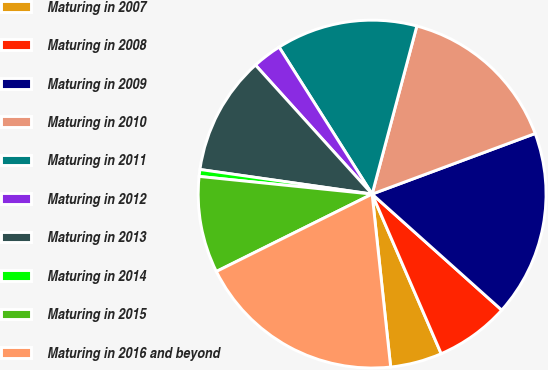Convert chart. <chart><loc_0><loc_0><loc_500><loc_500><pie_chart><fcel>Maturing in 2007<fcel>Maturing in 2008<fcel>Maturing in 2009<fcel>Maturing in 2010<fcel>Maturing in 2011<fcel>Maturing in 2012<fcel>Maturing in 2013<fcel>Maturing in 2014<fcel>Maturing in 2015<fcel>Maturing in 2016 and beyond<nl><fcel>4.8%<fcel>6.88%<fcel>17.28%<fcel>15.2%<fcel>13.12%<fcel>2.72%<fcel>11.04%<fcel>0.64%<fcel>8.96%<fcel>19.36%<nl></chart> 